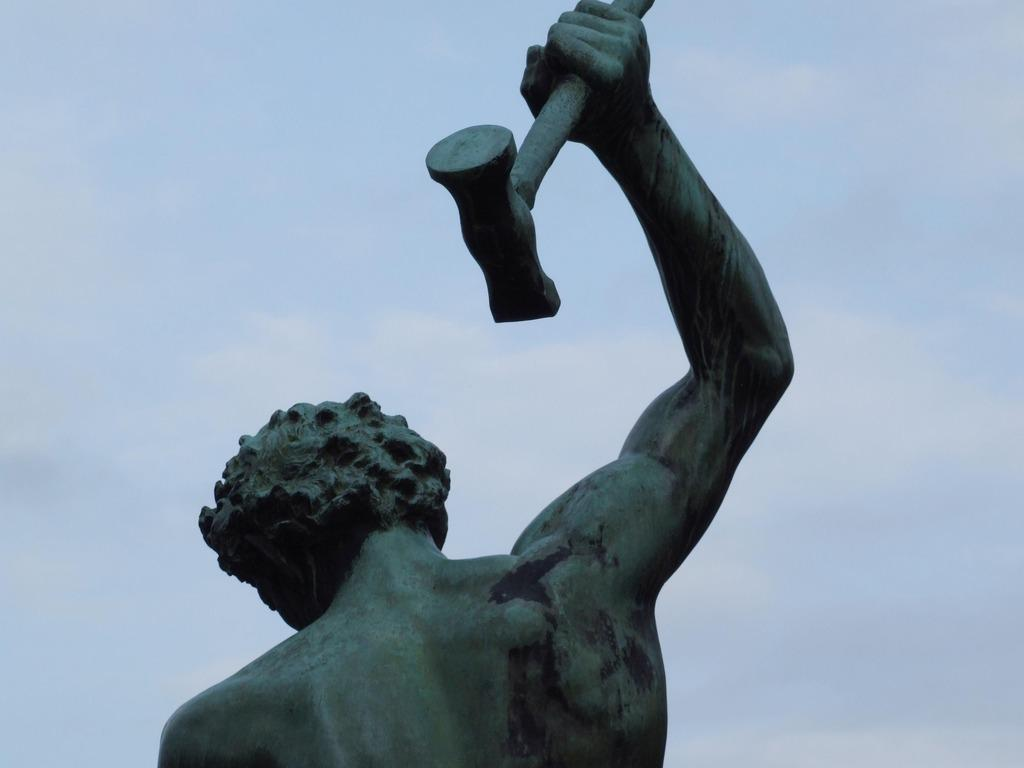What is the main subject of the picture? The main subject of the picture is a statue. Can you describe the statue? The statue is of a person. What is the person in the statue holding? The person is holding a hammer in his hand. How many vases are present in the image? There are no vases present in the image; it features a statue of a person holding a hammer. Can you describe the flock of birds in the image? There are no birds or flocks present in the image; it features a statue of a person holding a hammer. 